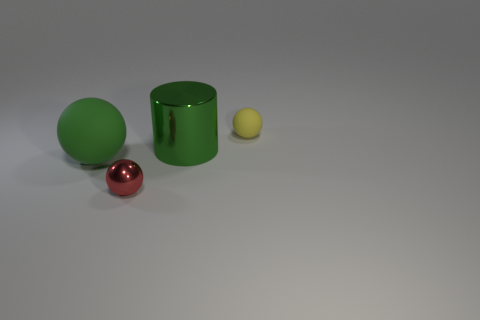There is another big object that is the same color as the large metallic object; what is it made of?
Keep it short and to the point. Rubber. What number of large blue matte things are the same shape as the big green matte object?
Offer a very short reply. 0. Is the number of red shiny objects left of the small red shiny object greater than the number of small gray metallic spheres?
Ensure brevity in your answer.  No. The large thing that is behind the matte ball in front of the matte thing that is on the right side of the large green metal cylinder is what shape?
Your answer should be compact. Cylinder. Do the green thing to the left of the red object and the large thing that is right of the tiny red object have the same shape?
Your answer should be very brief. No. Is there any other thing that is the same size as the red metal object?
Your answer should be compact. Yes. What number of cubes are either big rubber things or tiny yellow rubber objects?
Offer a terse response. 0. Does the large sphere have the same material as the green cylinder?
Provide a short and direct response. No. How many other objects are the same color as the metallic sphere?
Make the answer very short. 0. There is a matte thing that is left of the tiny yellow object; what is its shape?
Keep it short and to the point. Sphere. 